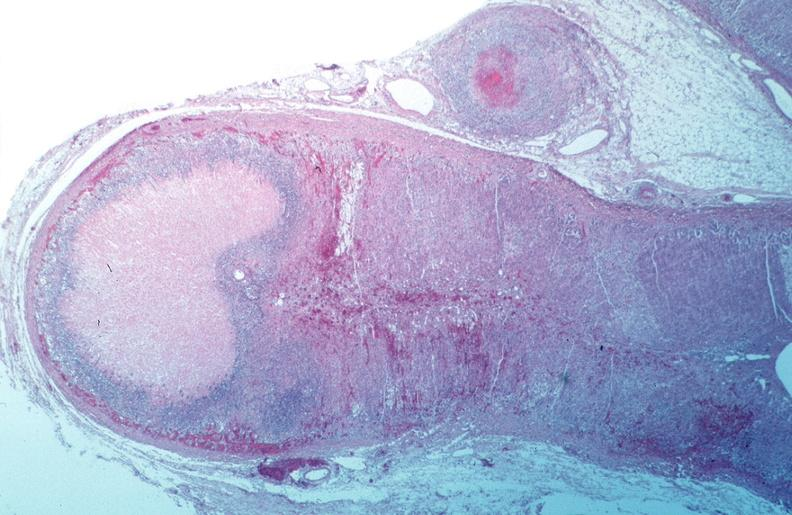what does this image show?
Answer the question using a single word or phrase. Vasculitis 